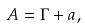<formula> <loc_0><loc_0><loc_500><loc_500>A = \Gamma + a ,</formula> 